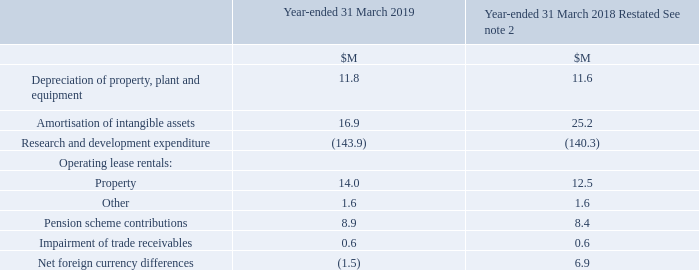9 Profit / (loss) on Ordinary Activities
The profit (2018: loss) on ordinary activities before taxation is stated after charging:
What is stated after charging the items in the table? The profit (2018: loss) on ordinary activities before taxation. What was the amount of Depreciation of property, plant and equipment in 2019?
Answer scale should be: million. 11.8. What are the components under Operating lease rentals in the table? Property, other. In which year was the amount of Property larger? 14.0>12.5
Answer: 2019. What was the change in the amount of Property in 2019 from 2018?
Answer scale should be: million. 14.0-12.5
Answer: 1.5. What was the percentage change in the amount of Property in 2019 from 2018?
Answer scale should be: percent. (14.0-12.5)/12.5
Answer: 12. 